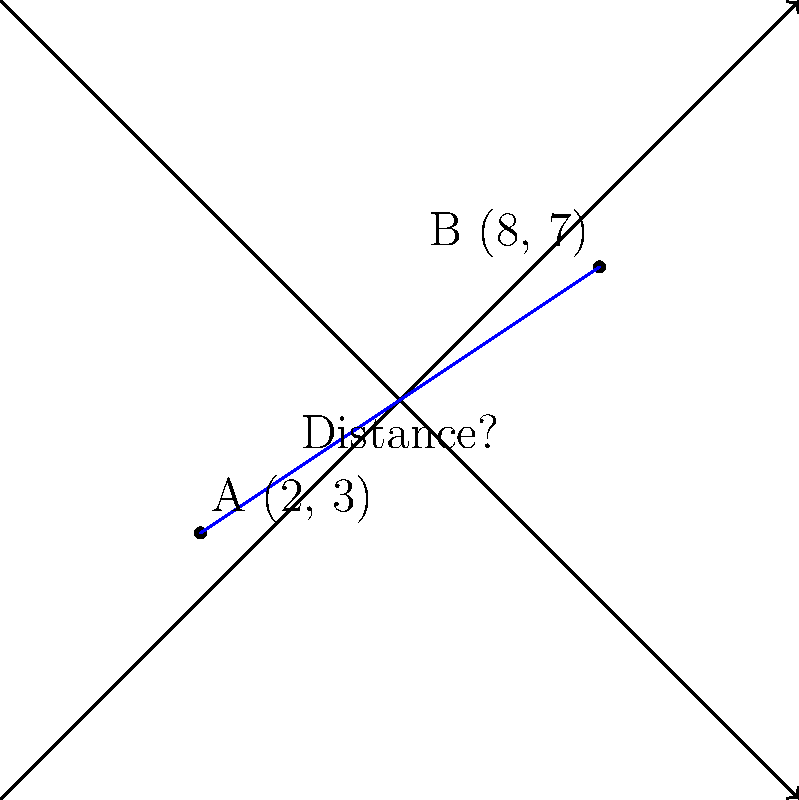Two patrol cars are positioned at different locations in the city. Car A is at coordinates (2, 3) and Car B is at coordinates (8, 7). Calculate the straight-line distance between these two patrol cars using the distance formula. To solve this problem, we'll use the distance formula derived from the Pythagorean theorem:

$$d = \sqrt{(x_2 - x_1)^2 + (y_2 - y_1)^2}$$

Where $(x_1, y_1)$ is the position of Car A and $(x_2, y_2)$ is the position of Car B.

Step 1: Identify the coordinates
Car A: $(x_1, y_1) = (2, 3)$
Car B: $(x_2, y_2) = (8, 7)$

Step 2: Plug the coordinates into the distance formula
$$d = \sqrt{(8 - 2)^2 + (7 - 3)^2}$$

Step 3: Simplify the expressions inside the parentheses
$$d = \sqrt{6^2 + 4^2}$$

Step 4: Calculate the squares
$$d = \sqrt{36 + 16}$$

Step 5: Add the numbers under the square root
$$d = \sqrt{52}$$

Step 6: Simplify the square root (if possible)
$\sqrt{52}$ can be simplified to $2\sqrt{13}$

Therefore, the distance between the two patrol cars is $2\sqrt{13}$ units.
Answer: $2\sqrt{13}$ units 